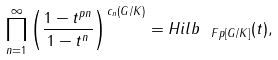Convert formula to latex. <formula><loc_0><loc_0><loc_500><loc_500>\prod _ { n = 1 } ^ { \infty } \left ( \frac { 1 - t ^ { p n } } { 1 - t ^ { n } } \right ) ^ { c _ { n } ( G / K ) } = H i l b _ { \ F p [ G / K ] } ( t ) ,</formula> 